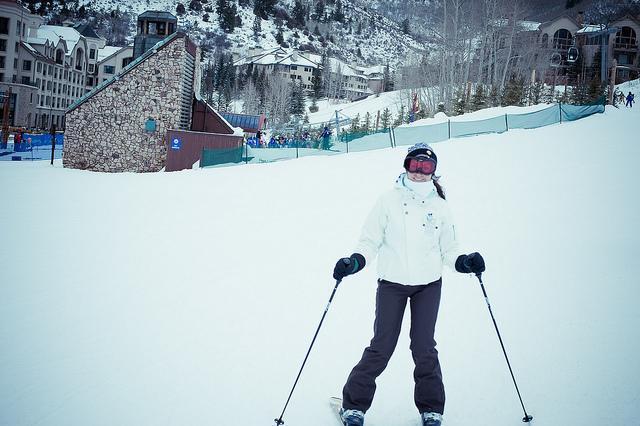How many bus on the road?
Give a very brief answer. 0. 